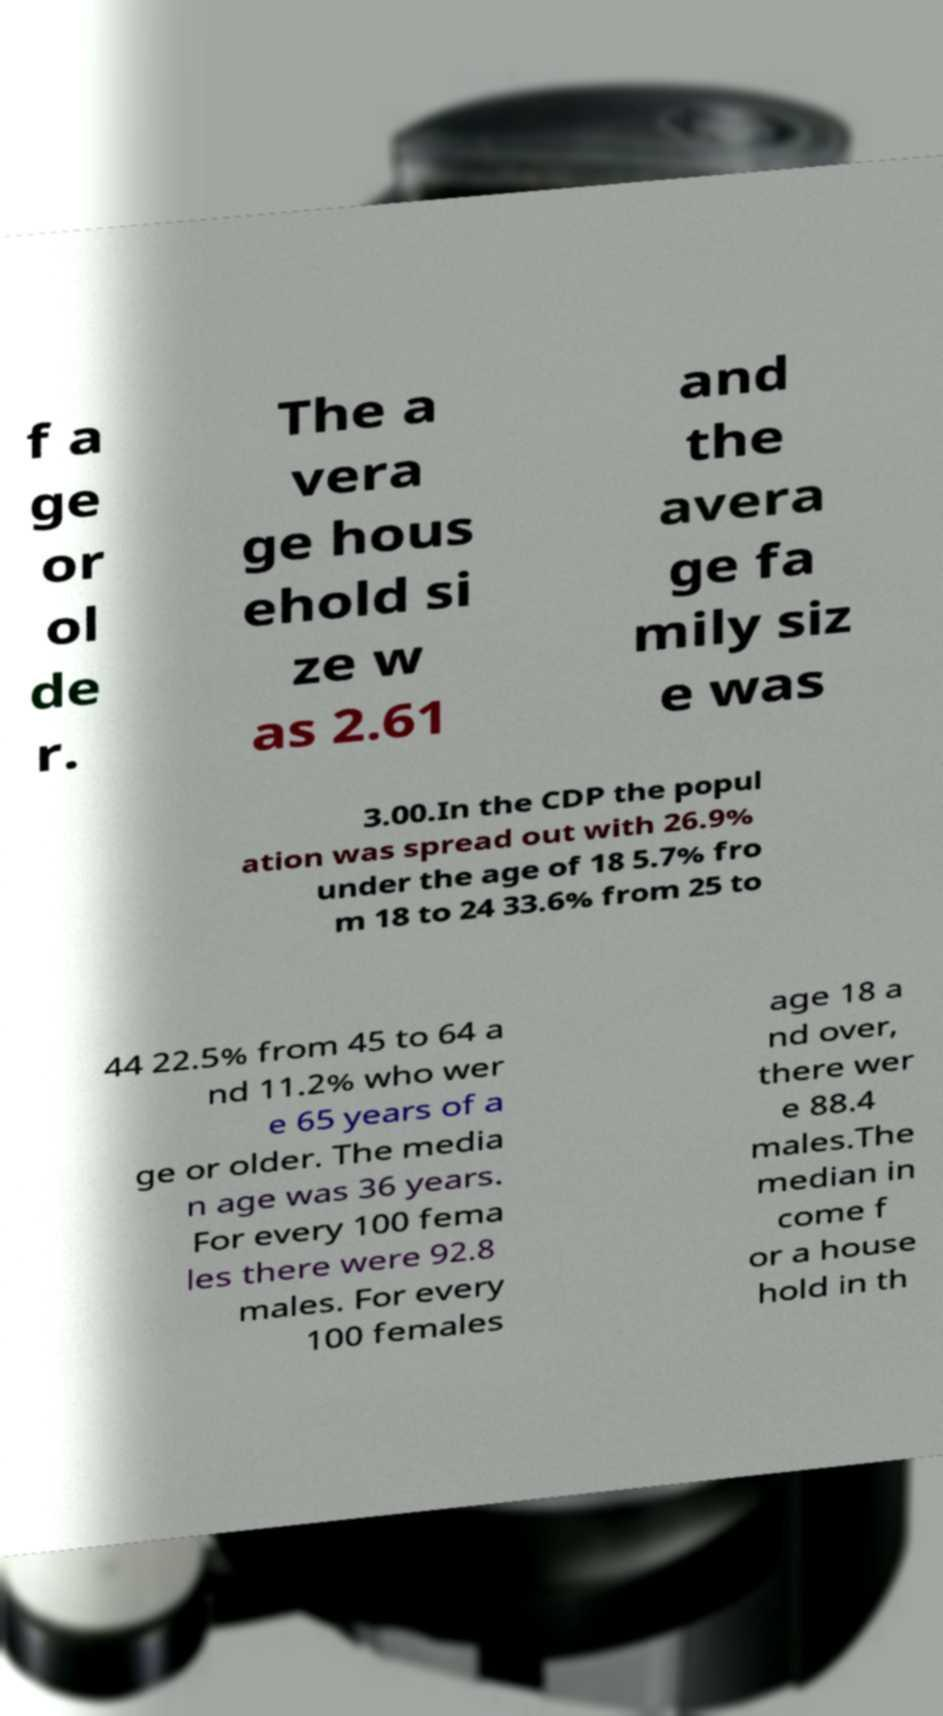For documentation purposes, I need the text within this image transcribed. Could you provide that? f a ge or ol de r. The a vera ge hous ehold si ze w as 2.61 and the avera ge fa mily siz e was 3.00.In the CDP the popul ation was spread out with 26.9% under the age of 18 5.7% fro m 18 to 24 33.6% from 25 to 44 22.5% from 45 to 64 a nd 11.2% who wer e 65 years of a ge or older. The media n age was 36 years. For every 100 fema les there were 92.8 males. For every 100 females age 18 a nd over, there wer e 88.4 males.The median in come f or a house hold in th 